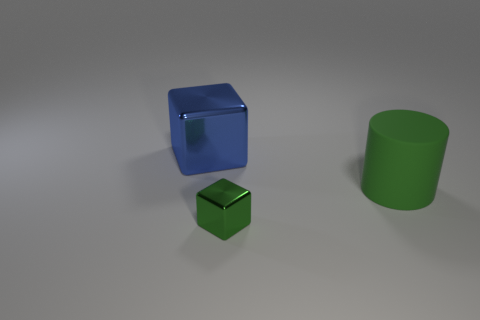Is there anything else that has the same material as the large cylinder?
Offer a terse response. No. What material is the object behind the matte object?
Make the answer very short. Metal. What is the color of the block that is made of the same material as the big blue thing?
Offer a terse response. Green. What number of green shiny blocks are the same size as the cylinder?
Keep it short and to the point. 0. There is a shiny object to the right of the blue cube; is it the same size as the green matte thing?
Give a very brief answer. No. What is the shape of the thing that is both in front of the blue object and behind the small shiny thing?
Ensure brevity in your answer.  Cylinder. There is a green rubber cylinder; are there any green cylinders in front of it?
Ensure brevity in your answer.  No. Is there anything else that has the same shape as the matte object?
Keep it short and to the point. No. Do the blue thing and the tiny thing have the same shape?
Give a very brief answer. Yes. Are there the same number of small shiny cubes on the right side of the large green matte cylinder and small cubes left of the tiny object?
Give a very brief answer. Yes. 